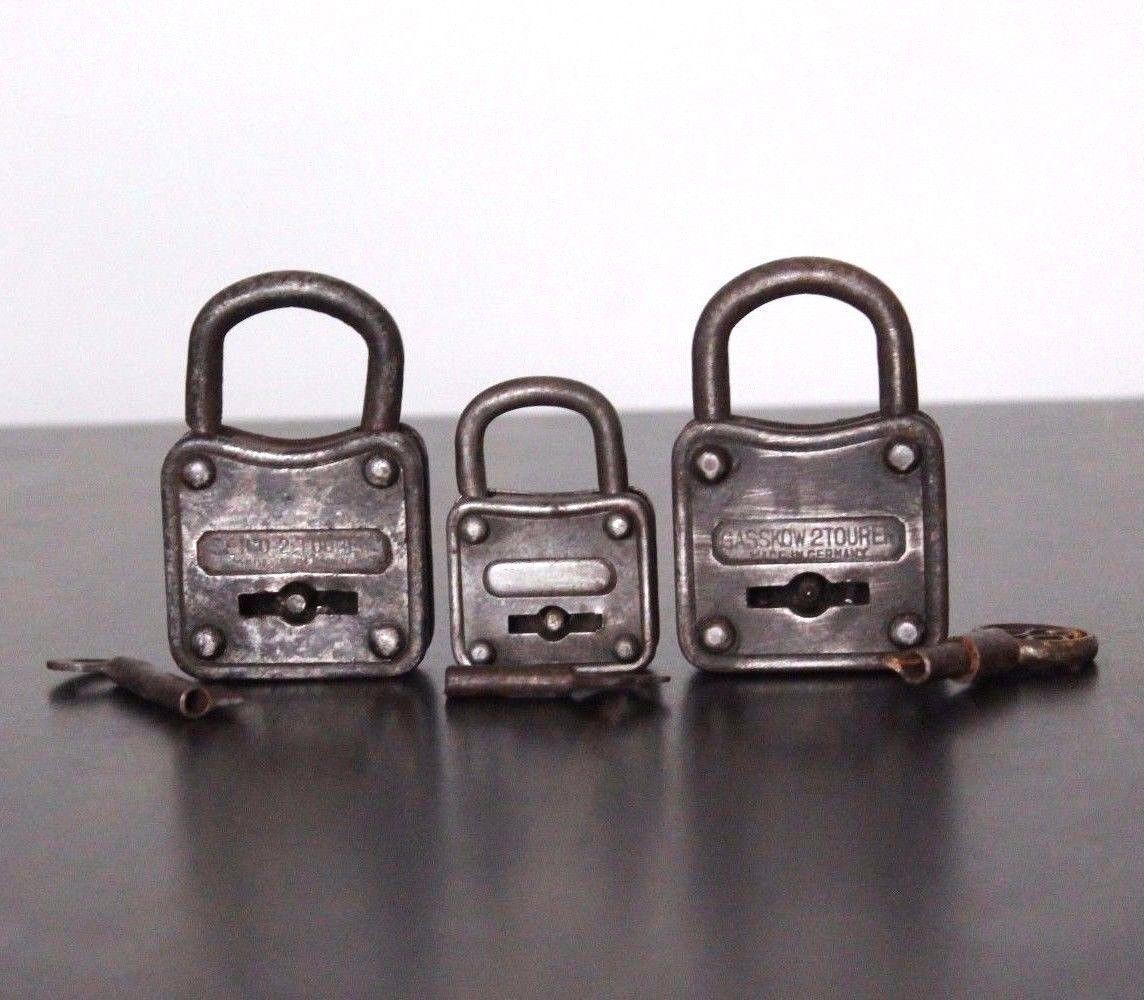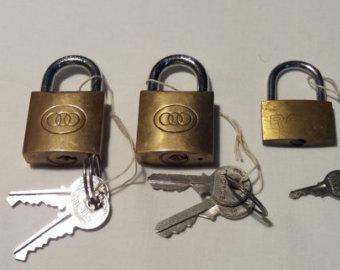The first image is the image on the left, the second image is the image on the right. For the images shown, is this caption "One image shows three antique padlocks with keyholes visible on the lower front panel of the padlock, with keys displayed in front of them." true? Answer yes or no. Yes. The first image is the image on the left, the second image is the image on the right. For the images shown, is this caption "There are three padlocks in total." true? Answer yes or no. No. 